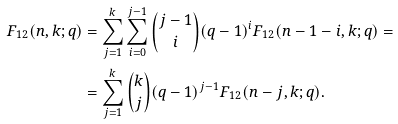<formula> <loc_0><loc_0><loc_500><loc_500>F _ { 1 2 } ( n , k ; q ) & = \sum _ { j = 1 } ^ { k } \sum _ { i = 0 } ^ { j - 1 } { \binom { j - 1 } { i } ( q - 1 ) ^ { i } F _ { 1 2 } ( n - 1 - i , k ; q ) } = \\ & = \sum _ { j = 1 } ^ { k } { \binom { k } { j } ( q - 1 ) ^ { j - 1 } F _ { 1 2 } ( n - j , k ; q ) } .</formula> 